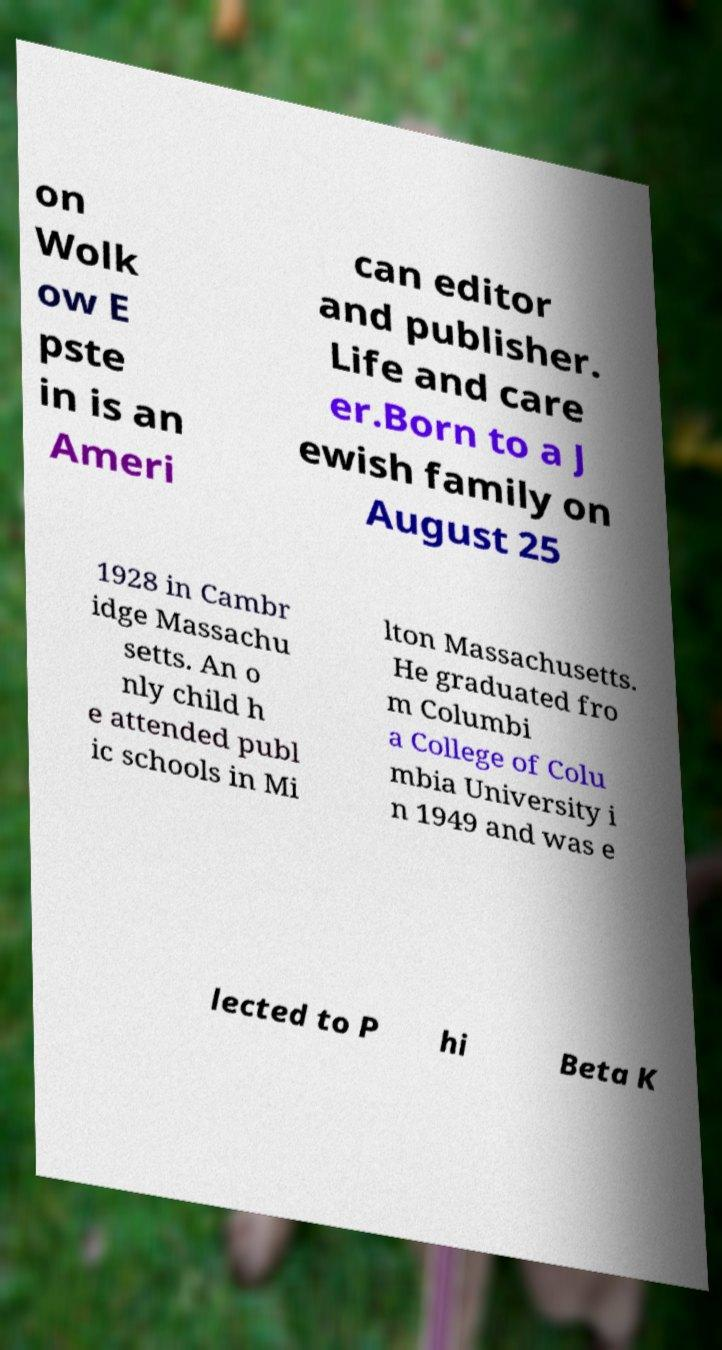Please identify and transcribe the text found in this image. on Wolk ow E pste in is an Ameri can editor and publisher. Life and care er.Born to a J ewish family on August 25 1928 in Cambr idge Massachu setts. An o nly child h e attended publ ic schools in Mi lton Massachusetts. He graduated fro m Columbi a College of Colu mbia University i n 1949 and was e lected to P hi Beta K 